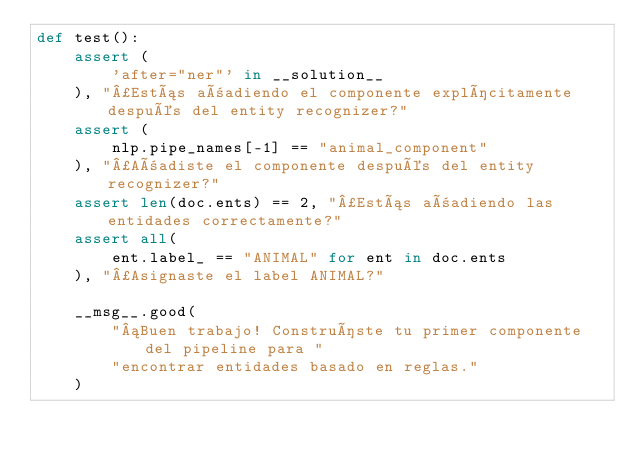<code> <loc_0><loc_0><loc_500><loc_500><_Python_>def test():
    assert (
        'after="ner"' in __solution__
    ), "¿Estás añadiendo el componente explícitamente después del entity recognizer?"
    assert (
        nlp.pipe_names[-1] == "animal_component"
    ), "¿Añadiste el componente después del entity recognizer?"
    assert len(doc.ents) == 2, "¿Estás añadiendo las entidades correctamente?"
    assert all(
        ent.label_ == "ANIMAL" for ent in doc.ents
    ), "¿Asignaste el label ANIMAL?"

    __msg__.good(
        "¡Buen trabajo! Construíste tu primer componente del pipeline para "
        "encontrar entidades basado en reglas."
    )
</code> 